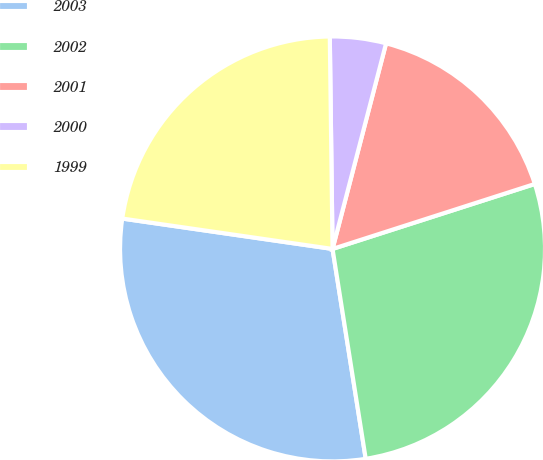Convert chart to OTSL. <chart><loc_0><loc_0><loc_500><loc_500><pie_chart><fcel>2003<fcel>2002<fcel>2001<fcel>2000<fcel>1999<nl><fcel>29.78%<fcel>27.45%<fcel>16.0%<fcel>4.26%<fcel>22.51%<nl></chart> 